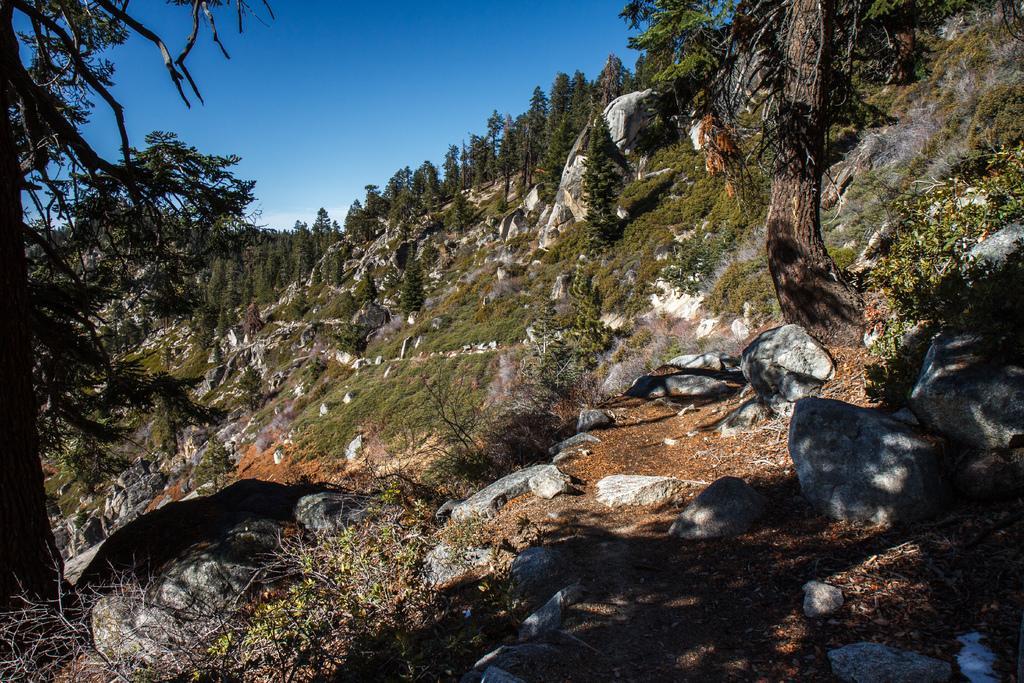In one or two sentences, can you explain what this image depicts? In this image I can see the stones. In the background, I can see the trees and clouds in the sky. 